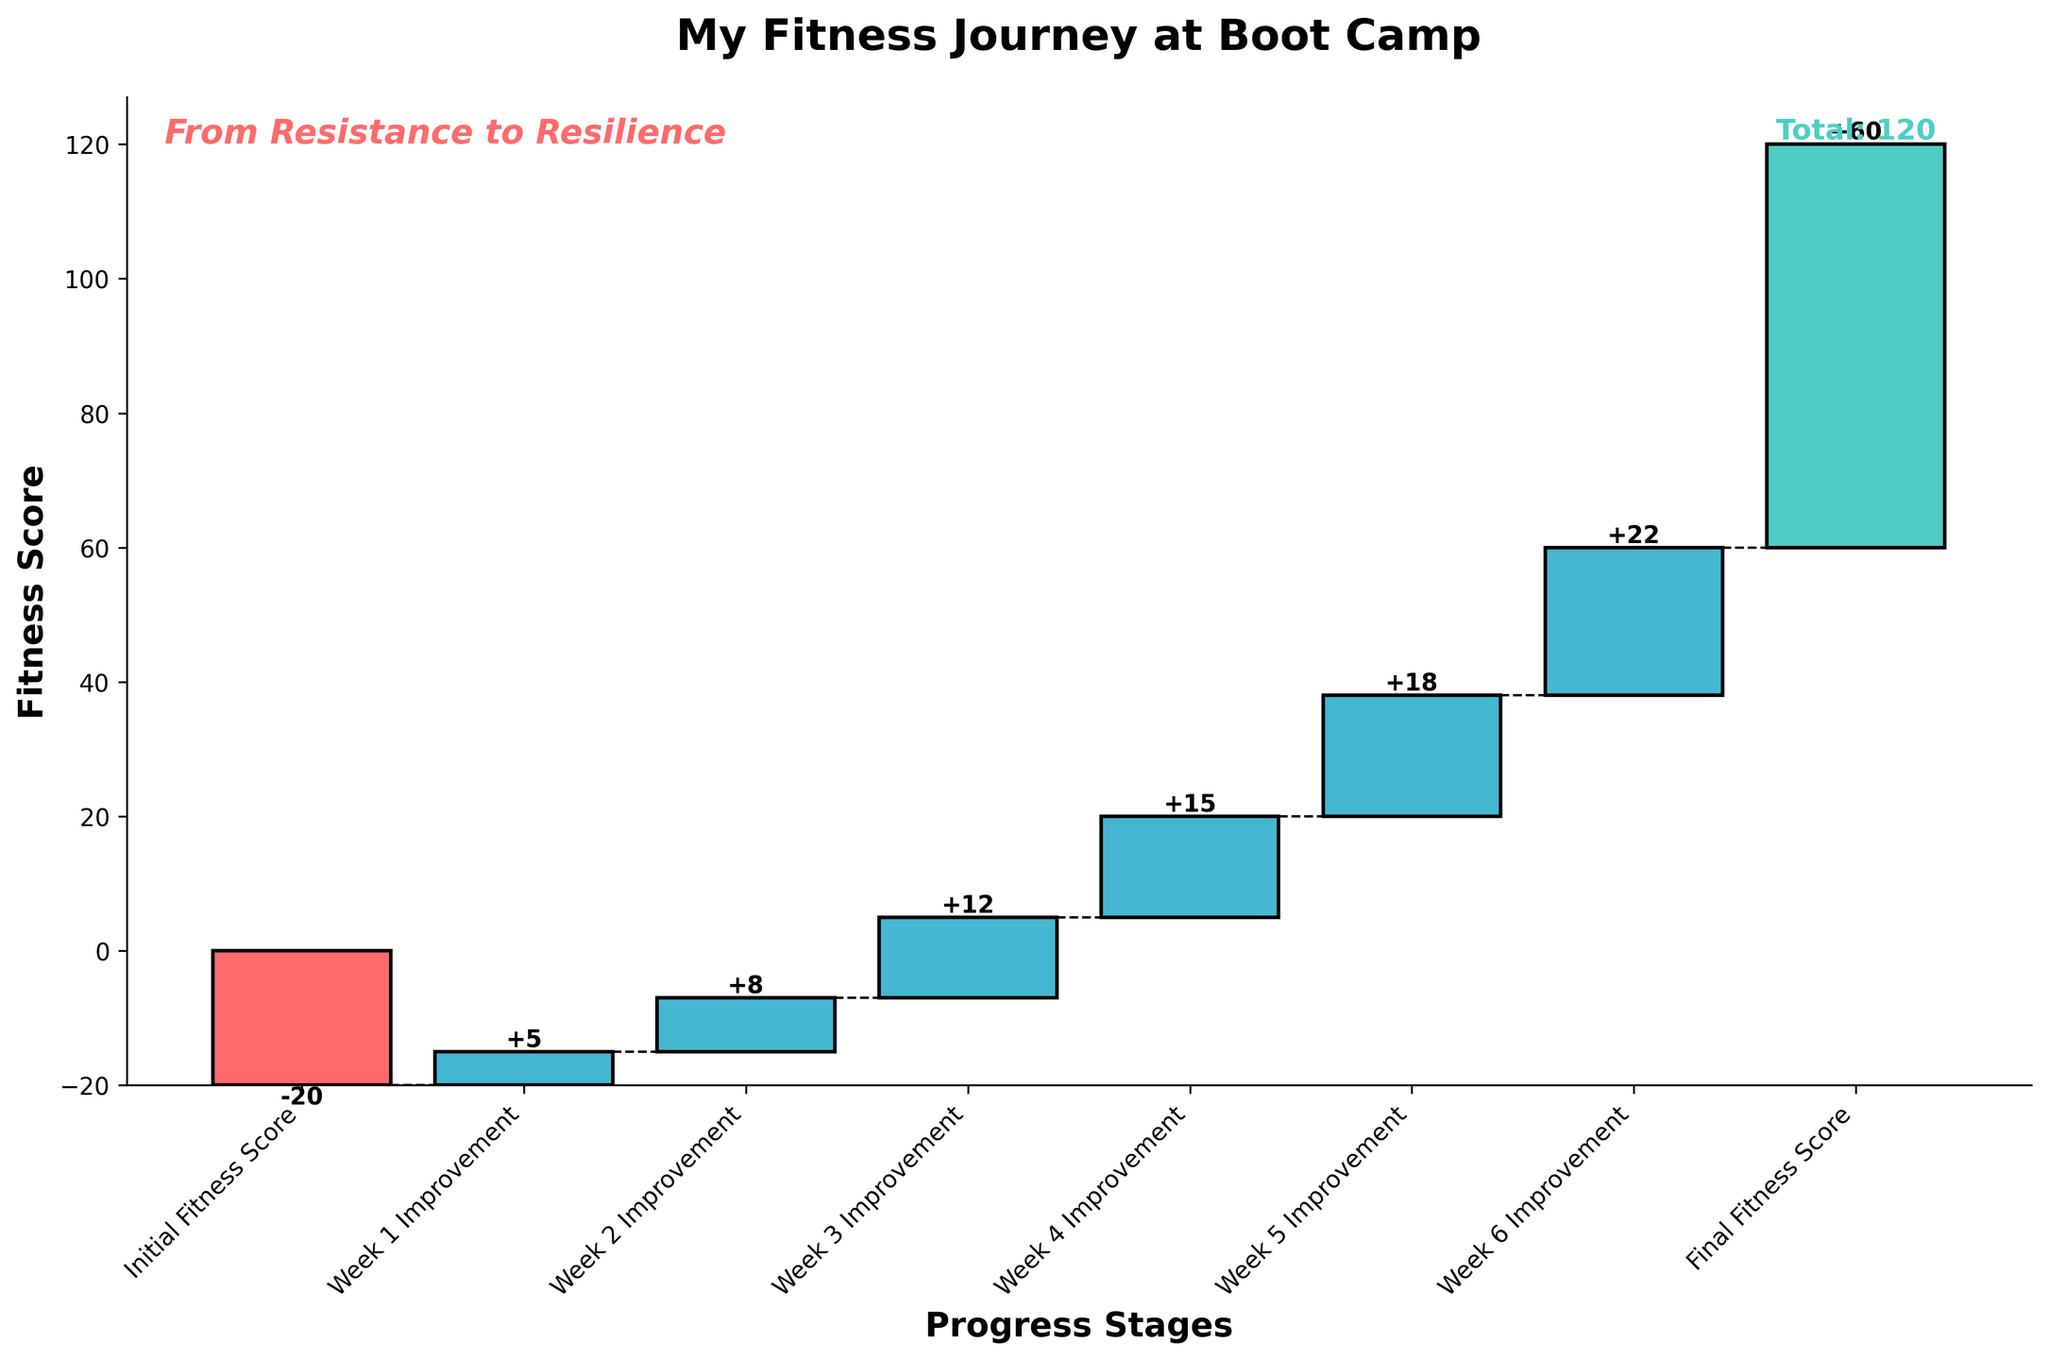What's the title of the chart? The title of a chart is typically displayed at the top and in this case, it reads "My Fitness Journey at Boot Camp".
Answer: My Fitness Journey at Boot Camp What is the initial fitness score at the start of the boot camp? The initial fitness score is displayed as the first bar on the left, which is labeled "Initial Fitness Score" with a value clearly shown as -20.
Answer: -20 How many weeks are represented in the chart, excluding the initial and final scores? The chart shows individual bars for each week labeled "Week 1 Improvement" to "Week 6 Improvement", indicating 6 weeks of data.
Answer: 6 weeks What's the improvement in Week 4? The bar labeled "Week 4 Improvement" indicates an improvement of 15 points, which is displayed above the bar.
Answer: 15 What is the final fitness score after Week 6? The final fitness score is displayed as the last bar on the right and is labeled "Final Fitness Score" with a value of 60.
Answer: 60 What is the total improvement from Week 1 to Week 6? To get the total improvement, sum the individual weekly improvements: 5 + 8 + 12 + 15 + 18 + 22 = 80.
Answer: 80 Which week showed the greatest improvement? By comparing the heights and values of the bars for each week, Week 6 shows the greatest improvement with a value of 22.
Answer: Week 6 How does the final fitness score compare to the initial fitness score? The initial fitness score is -20 and the final fitness score is 60. The difference can be found by calculating 60 - (-20) = 80. The final score is 80 points higher than the initial score.
Answer: 80 points higher What is the cumulative fitness score at the end of Week 3? Starting from an initial score of -20, add the improvements for the first three weeks: -20 + 5 + 8 + 12 = 5. So the cumulative score at the end of Week 3 is 5.
Answer: 5 